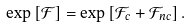Convert formula to latex. <formula><loc_0><loc_0><loc_500><loc_500>\exp { [ \mathcal { F } ] } = \exp { [ \mathcal { F } _ { c } + \mathcal { F } _ { n c } ] } \, .</formula> 